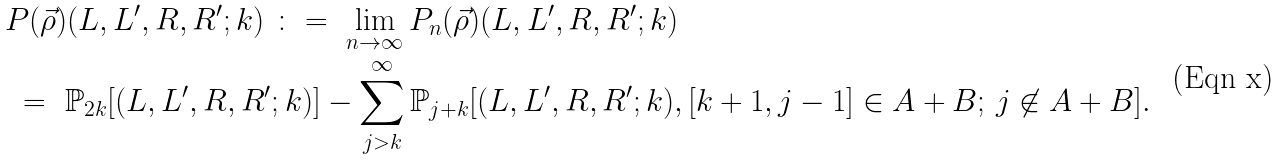Convert formula to latex. <formula><loc_0><loc_0><loc_500><loc_500>& P ( \vec { \rho } ) ( L , L ^ { \prime } , R , R ^ { \prime } ; k ) \ \colon = \ \lim _ { n \to \infty } P _ { n } ( \vec { \rho } ) ( L , L ^ { \prime } , R , R ^ { \prime } ; k ) \\ & \ = \ \mathbb { P } _ { 2 k } [ ( L , L ^ { \prime } , R , R ^ { \prime } ; k ) ] - \sum _ { j > k } ^ { \infty } \mathbb { P } _ { j + k } [ ( L , L ^ { \prime } , R , R ^ { \prime } ; k ) , [ k + 1 , j - 1 ] \in A + B ; \, j \not \in A + B ] .</formula> 